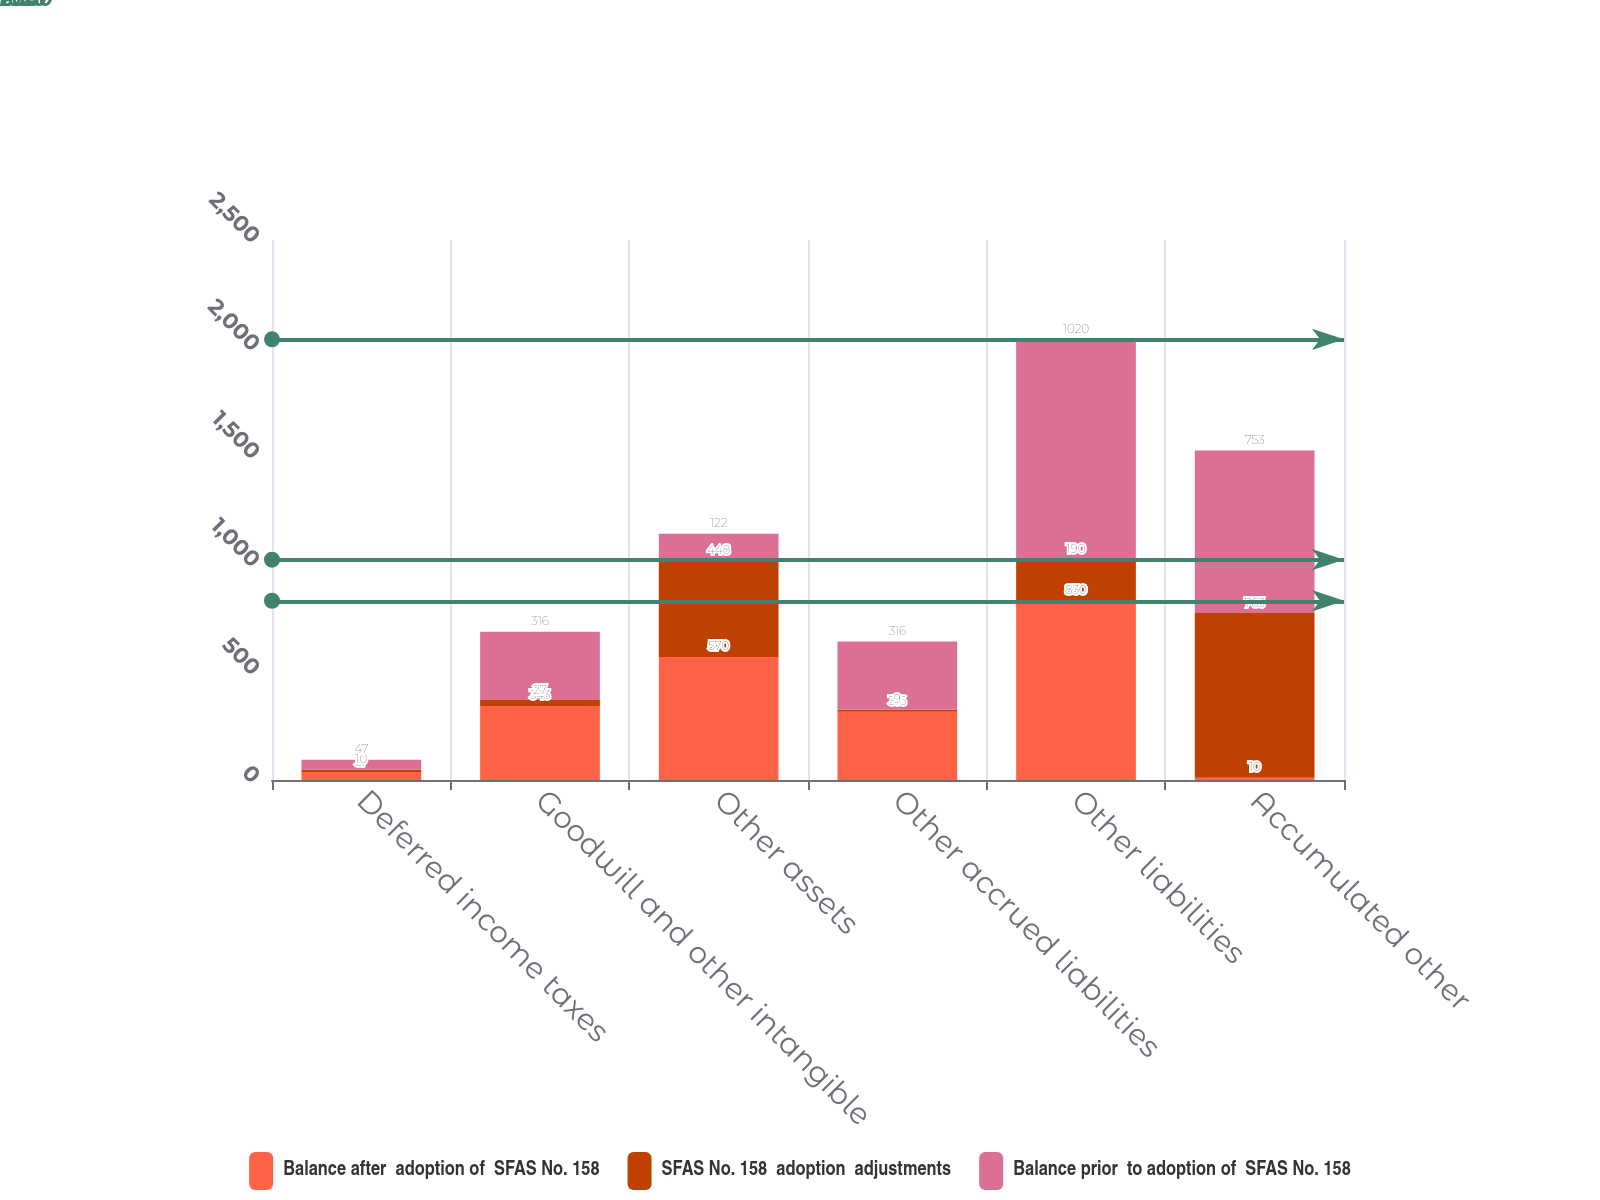Convert chart to OTSL. <chart><loc_0><loc_0><loc_500><loc_500><stacked_bar_chart><ecel><fcel>Deferred income taxes<fcel>Goodwill and other intangible<fcel>Other assets<fcel>Other accrued liabilities<fcel>Other liabilities<fcel>Accumulated other<nl><fcel>Balance after  adoption of  SFAS No. 158<fcel>37<fcel>343<fcel>570<fcel>316<fcel>830<fcel>10<nl><fcel>SFAS No. 158  adoption  adjustments<fcel>10<fcel>27<fcel>448<fcel>9<fcel>190<fcel>763<nl><fcel>Balance prior  to adoption of  SFAS No. 158<fcel>47<fcel>316<fcel>122<fcel>316<fcel>1020<fcel>753<nl></chart> 